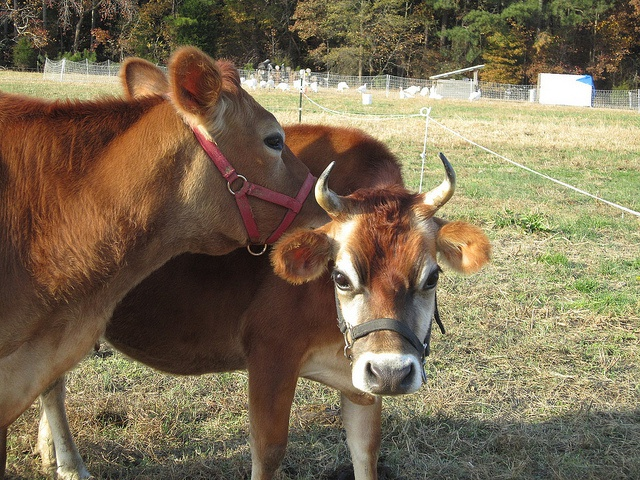Describe the objects in this image and their specific colors. I can see cow in black, maroon, brown, and gray tones and cow in black, maroon, and gray tones in this image. 